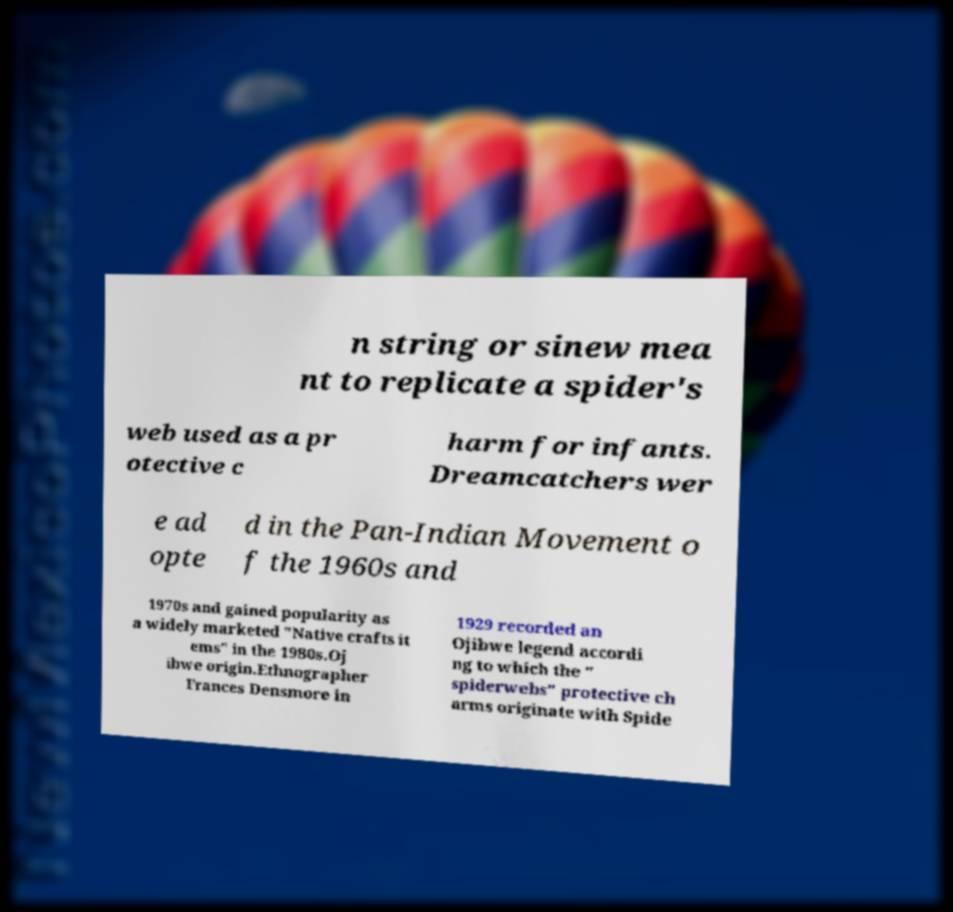Please identify and transcribe the text found in this image. n string or sinew mea nt to replicate a spider's web used as a pr otective c harm for infants. Dreamcatchers wer e ad opte d in the Pan-Indian Movement o f the 1960s and 1970s and gained popularity as a widely marketed "Native crafts it ems" in the 1980s.Oj ibwe origin.Ethnographer Frances Densmore in 1929 recorded an Ojibwe legend accordi ng to which the " spiderwebs" protective ch arms originate with Spide 